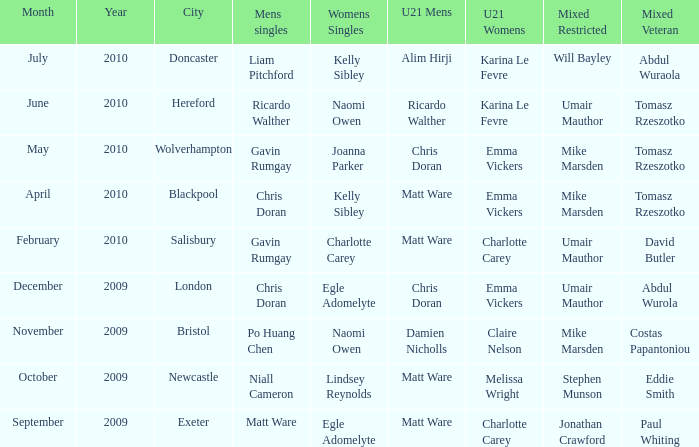When and where did Eddie Smith win the mixed veteran? 1.0. 